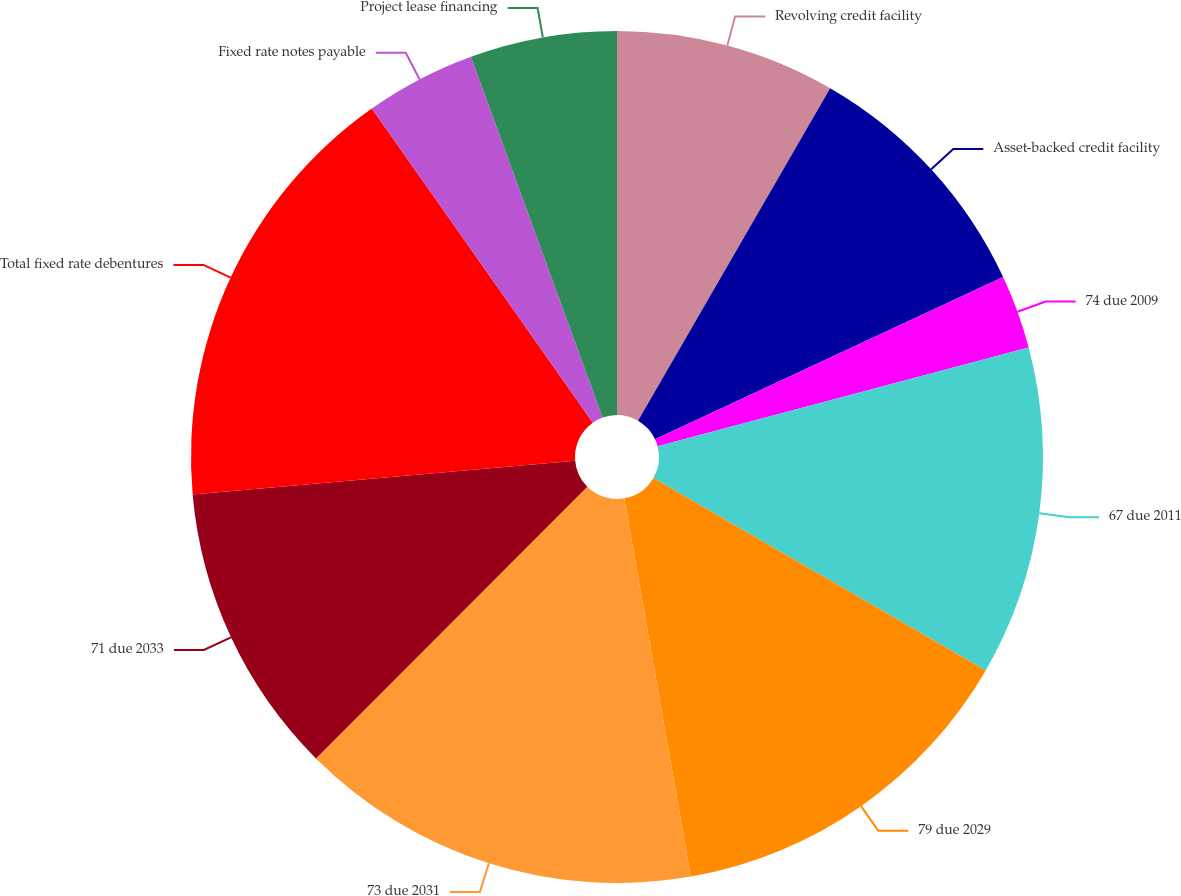Convert chart. <chart><loc_0><loc_0><loc_500><loc_500><pie_chart><fcel>Revolving credit facility<fcel>Asset-backed credit facility<fcel>74 due 2009<fcel>67 due 2011<fcel>79 due 2029<fcel>73 due 2031<fcel>71 due 2033<fcel>Total fixed rate debentures<fcel>Fixed rate notes payable<fcel>Project lease financing<nl><fcel>8.34%<fcel>9.72%<fcel>2.8%<fcel>12.49%<fcel>13.88%<fcel>15.26%<fcel>11.11%<fcel>16.64%<fcel>4.19%<fcel>5.57%<nl></chart> 